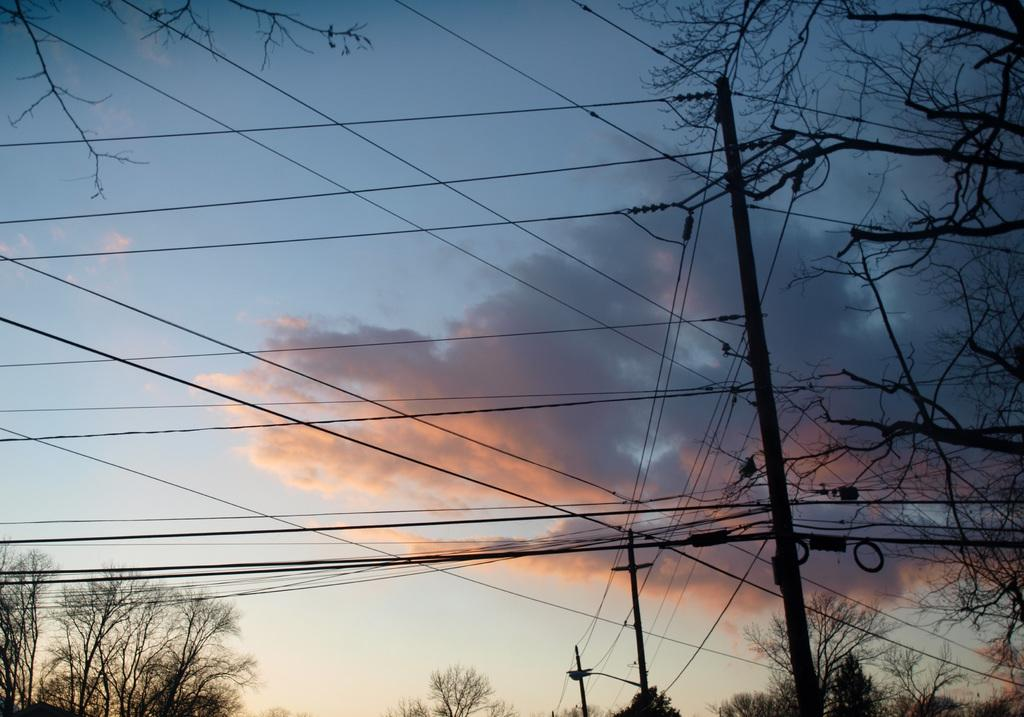What structures can be seen in the image? There are poles and wires in the image. What type of vegetation is at the bottom of the image? There are trees at the bottom of the image. What part of the natural environment is visible in the image? The sky is visible in the image. What can be seen in the sky? Clouds are present in the sky. How many brothers are depicted in the image? There are no people, including brothers, present in the image. 